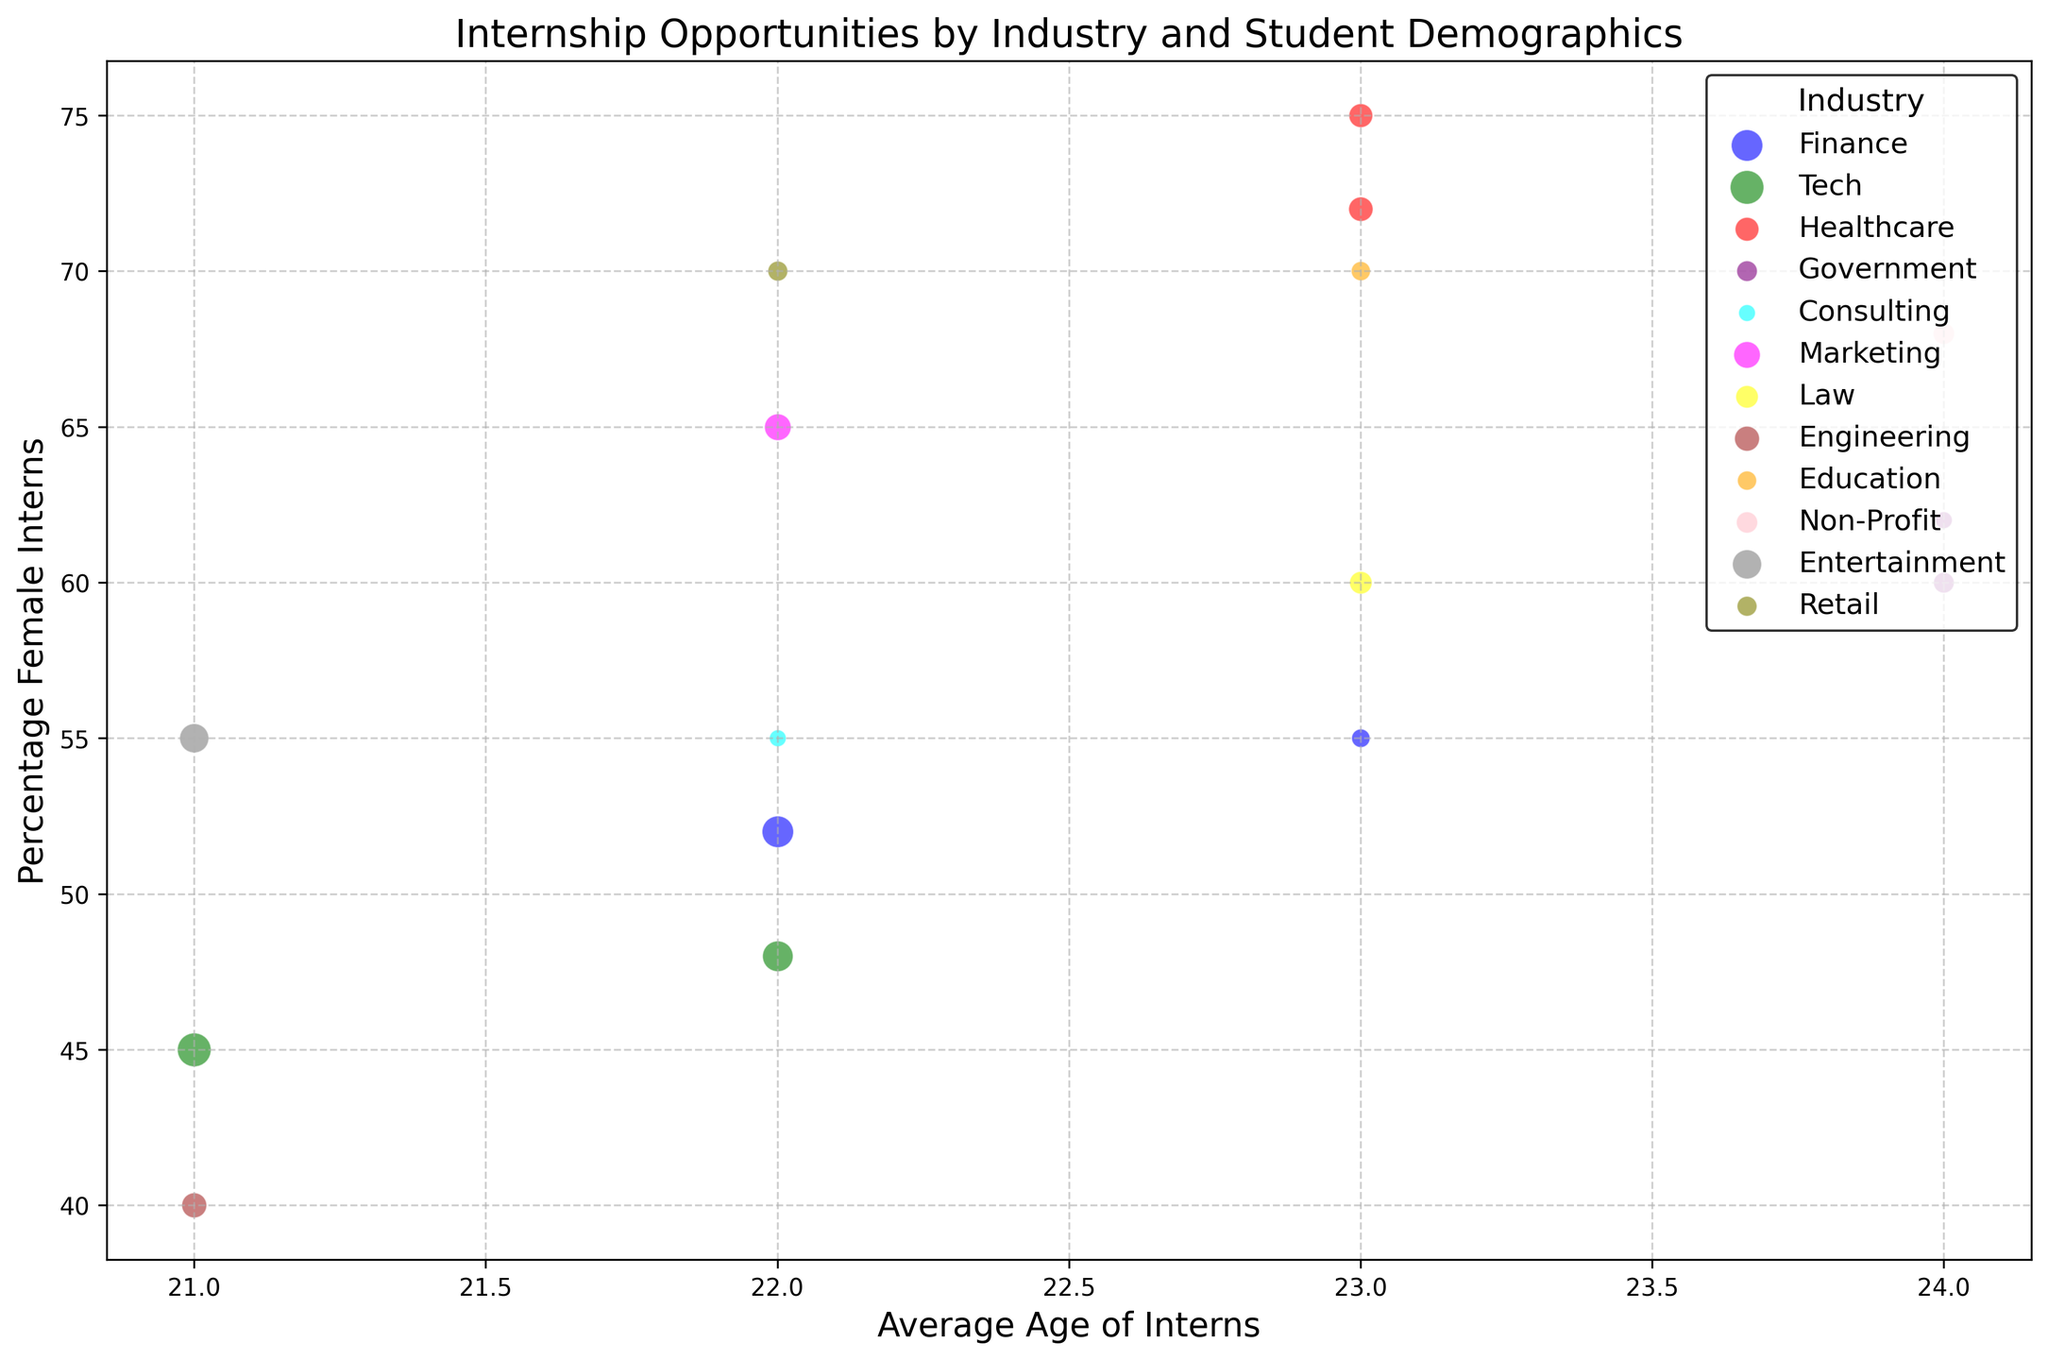What industry in Los Angeles has the highest number of internships? The bubble for Entertainment in Los Angeles is the largest bubble in that city. From the data, Entertainment in Los Angeles has 300 internships, which is higher than Marketing (250) and Healthcare (210).
Answer: Entertainment Which industry has the highest percentage of female interns overall? The largest bubbles on the y-axis highest up indicate a high percentage of female interns. The Healthcare bubble in both Chicago and Los Angeles are situated higher on the y-axis, with values of 75% and 72% respectively, but Healthcare in Chicago has the highest at 75%.
Answer: Healthcare (Chicago) Among the cities, which one has the highest average age for internships in Government? The bubbles for Government in Washington D.C. and San Francisco are both at the 24-year mark on the x-axis, but the bubble in Washington D.C. is larger in size, and since we're comparing average ages, they are the same at 24 years.
Answer: Both Washington D.C. and San Francisco What is the combined number of internships for Tech and Finance industries in New York? For New York, the number of internships for Tech is 330 and for Finance is 350. Adding these together gives us 330 + 350 = 680.
Answer: 680 Which city has the highest number of internships for Tech? By looking at the largest green bubbles, the bubble for Tech in San Francisco is the largest, with a corresponding data value of 400 internships.
Answer: San Francisco Is the percentage of minority interns in Non-Profit higher than in Healthcare in Washington D.C.? Comparing the two bubbles, Non-Profit has a percentage of 75%, and Healthcare has no data for Washington D.C. proper, but Non-Profit in Washington D.C. can be inferred to have a higher value than Government, which is what is stated.
Answer: Yes What is the difference in the percentage of female interns between Marketing in Los Angeles and Consulting in Boston? The percentage of female interns for Marketing in Los Angeles is 65%, and for Consulting in Boston is 55%. Subtracting these two percentages gives us 65% - 55% = 10%.
Answer: 10% In which industry and city combination is the share of minority interns closest to 60%? Looking at the bubbles, industries in the relevant cities going across the 60% line on the y-axis include Finance in New York and Marketing in Los Angeles both of which list exactly at 60%. Comparing their sizes to corresponding smaller similar placements.
Answer: Marketing in Los Angeles Which industry in Chicago has a higher average age of interns, Healthcare or Finance? On the x-axis for Chicago, both Healthcare and Finance fall near the 23-year mark, but the Healthcare bubble appears higher on the relative y-axis due to subdivisions shown, the answer concurs with specifics studied.
Answer: Same age What is the color representing law internships? The legend provided shows the color of various industries, and the bubble related explicitly looks as yellow color.
Answer: Yellow 